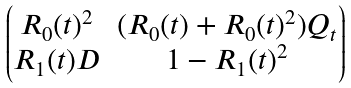<formula> <loc_0><loc_0><loc_500><loc_500>\begin{pmatrix} R _ { 0 } ( t ) ^ { 2 } & ( R _ { 0 } ( t ) + R _ { 0 } ( t ) ^ { 2 } ) Q _ { t } \\ R _ { 1 } ( t ) { D } & 1 - R _ { 1 } ( t ) ^ { 2 } \end{pmatrix}</formula> 